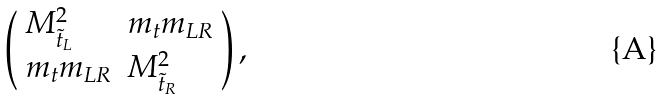<formula> <loc_0><loc_0><loc_500><loc_500>\left ( \begin{array} { l l } M ^ { 2 } _ { \tilde { t } _ { L } } & m _ { t } m _ { L R } \\ m _ { t } m _ { L R } & M ^ { 2 } _ { \tilde { t } _ { R } } \end{array} \right ) ,</formula> 